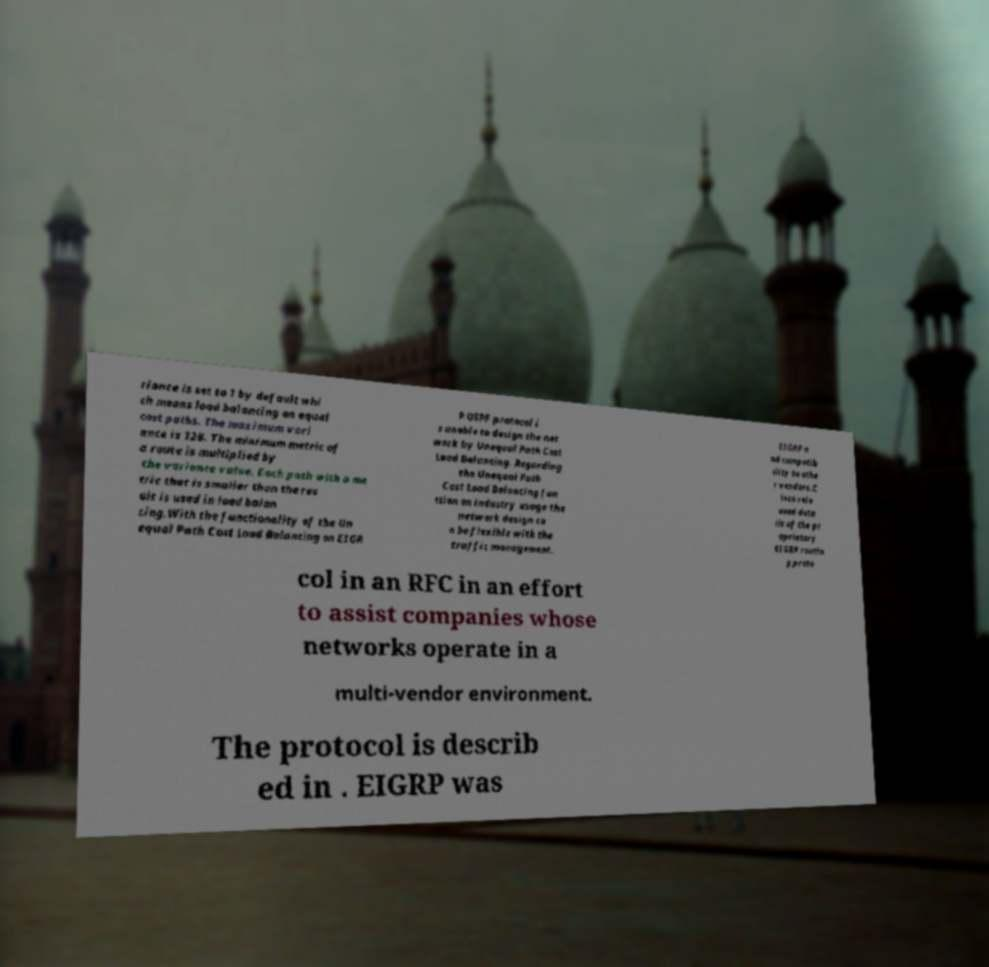For documentation purposes, I need the text within this image transcribed. Could you provide that? riance is set to 1 by default whi ch means load balancing on equal cost paths. The maximum vari ance is 128. The minimum metric of a route is multiplied by the variance value. Each path with a me tric that is smaller than the res ult is used in load balan cing.With the functionality of the Un equal Path Cost Load Balancing on EIGR P OSPF protocol i s unable to design the net work by Unequal Path Cost Load Balancing. Regarding the Unequal Path Cost Load Balancing fun ction on industry usage the network design ca n be flexible with the traffic management. EIGRP a nd compatib ility to othe r vendors.C isco rele ased deta ils of the pr oprietary EIGRP routin g proto col in an RFC in an effort to assist companies whose networks operate in a multi-vendor environment. The protocol is describ ed in . EIGRP was 